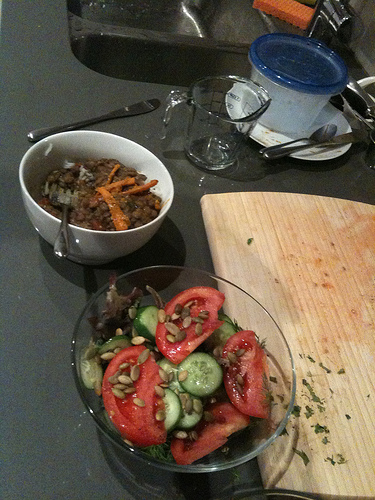<image>
Is the salad bowl in front of the fork? No. The salad bowl is not in front of the fork. The spatial positioning shows a different relationship between these objects. 